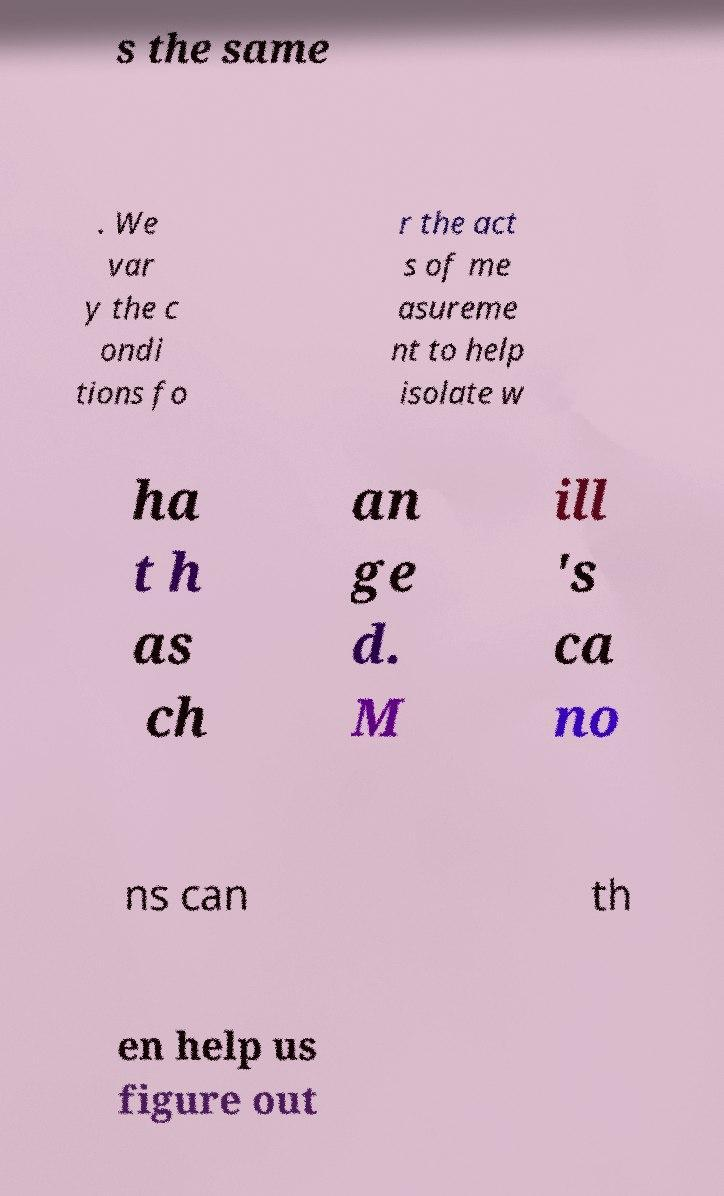Could you assist in decoding the text presented in this image and type it out clearly? s the same . We var y the c ondi tions fo r the act s of me asureme nt to help isolate w ha t h as ch an ge d. M ill 's ca no ns can th en help us figure out 